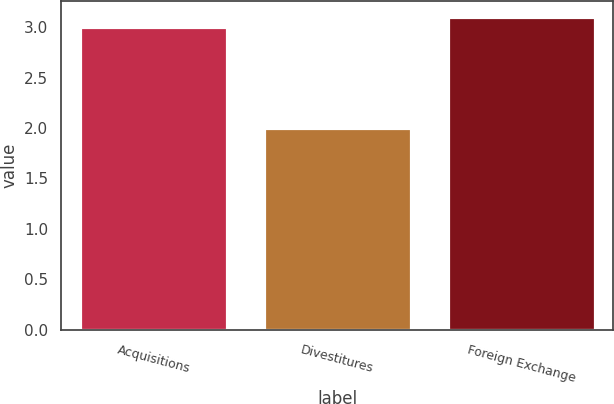Convert chart to OTSL. <chart><loc_0><loc_0><loc_500><loc_500><bar_chart><fcel>Acquisitions<fcel>Divestitures<fcel>Foreign Exchange<nl><fcel>3<fcel>2<fcel>3.1<nl></chart> 